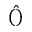Convert formula to latex. <formula><loc_0><loc_0><loc_500><loc_500>\hat { ( ) }</formula> 